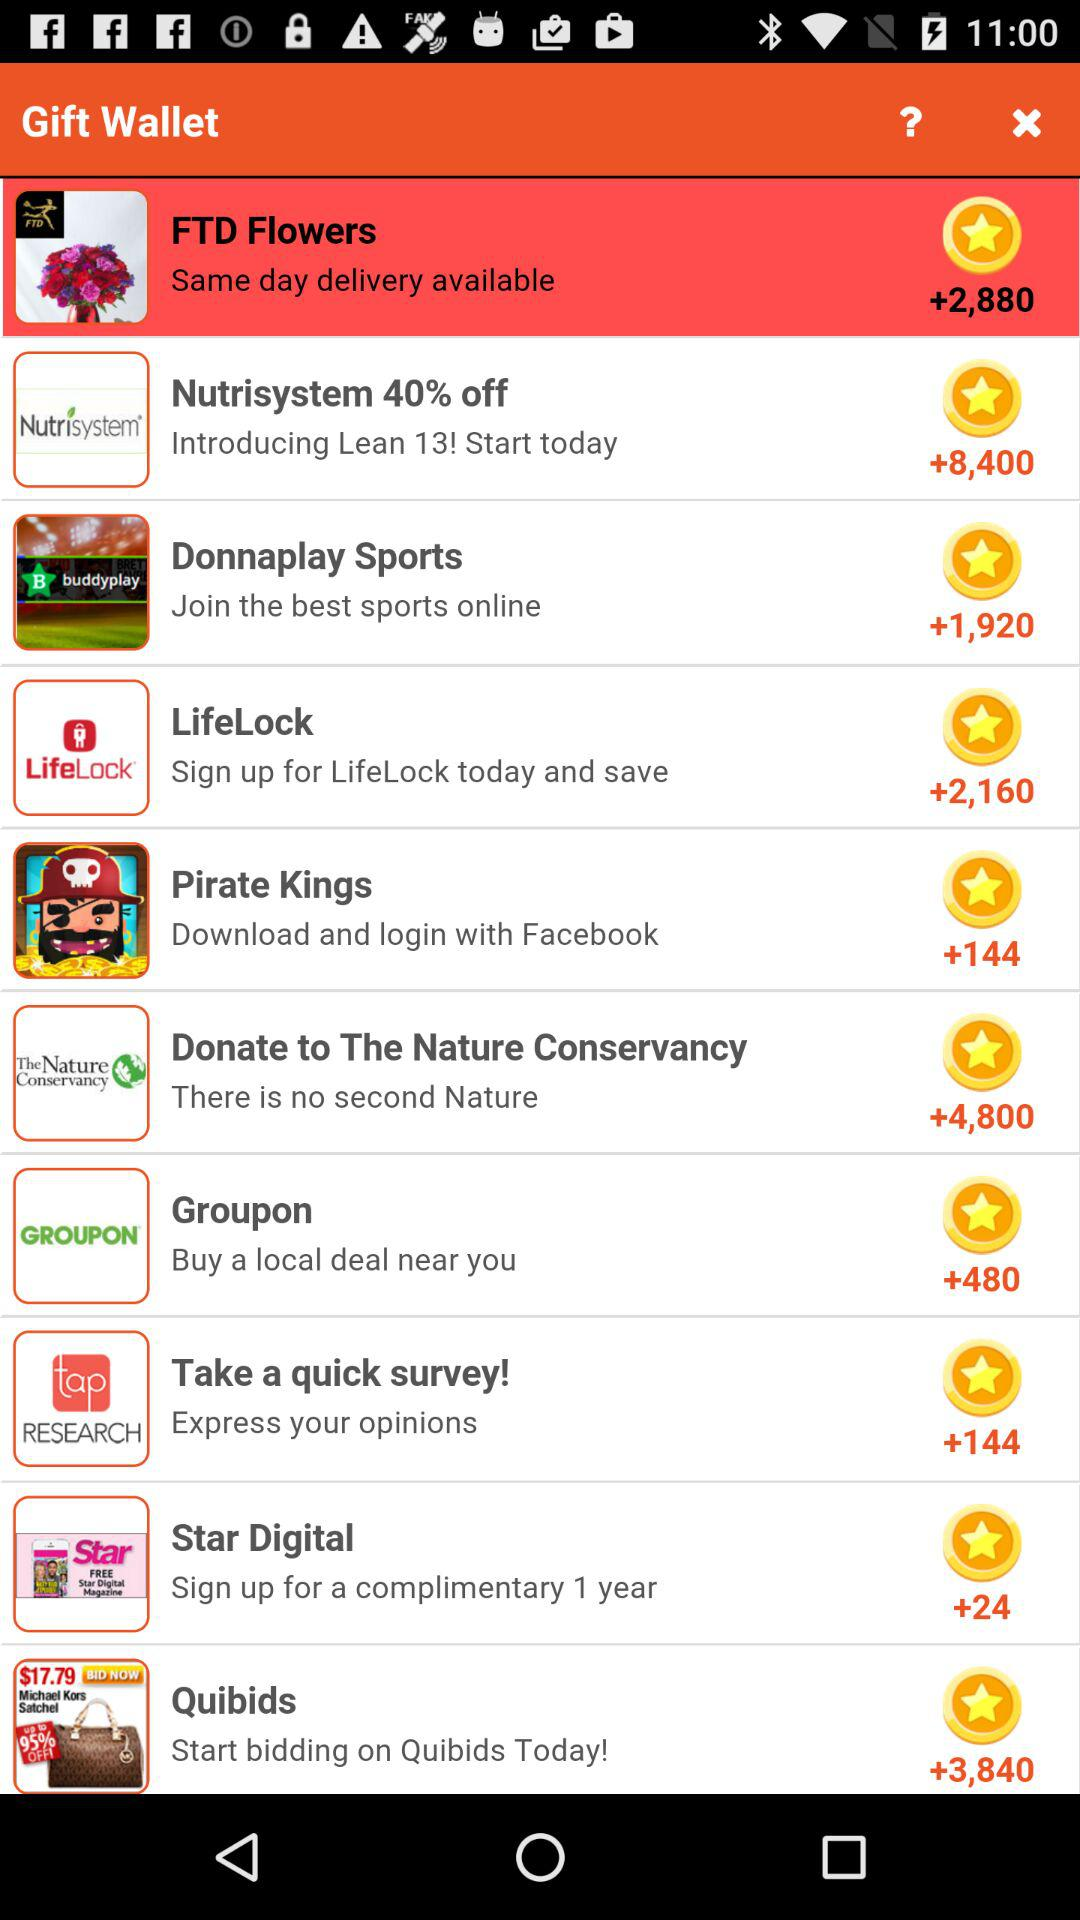Which gifts have same-day delivery available? The same-day delivery available for "FTD Flowers". 